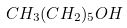<formula> <loc_0><loc_0><loc_500><loc_500>C H _ { 3 } ( C H _ { 2 } ) _ { 5 } O H</formula> 